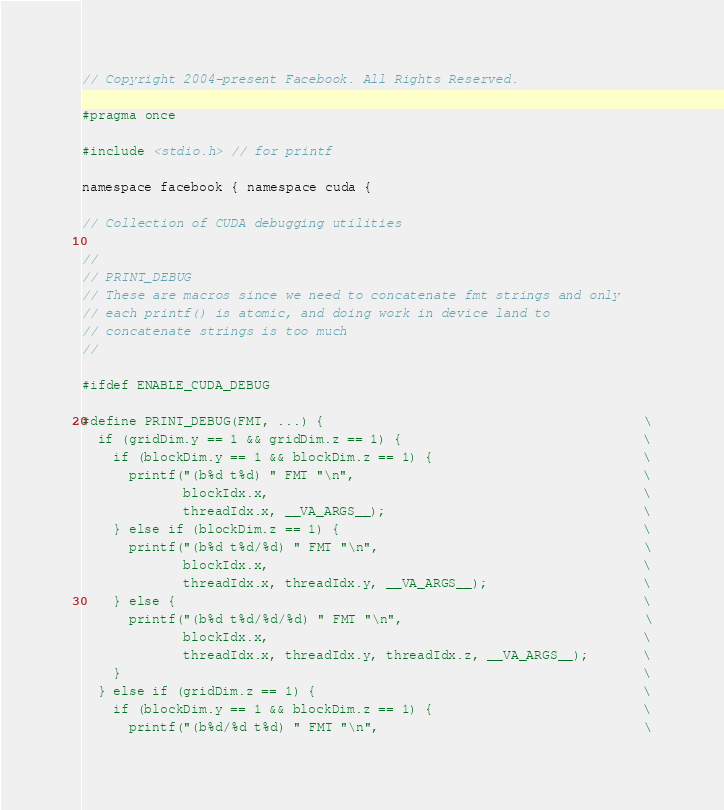Convert code to text. <code><loc_0><loc_0><loc_500><loc_500><_Cuda_>// Copyright 2004-present Facebook. All Rights Reserved.

#pragma once

#include <stdio.h> // for printf

namespace facebook { namespace cuda {

// Collection of CUDA debugging utilities

//
// PRINT_DEBUG
// These are macros since we need to concatenate fmt strings and only
// each printf() is atomic, and doing work in device land to
// concatenate strings is too much
//

#ifdef ENABLE_CUDA_DEBUG

#define PRINT_DEBUG(FMT, ...) {                                         \
  if (gridDim.y == 1 && gridDim.z == 1) {                               \
    if (blockDim.y == 1 && blockDim.z == 1) {                           \
      printf("(b%d t%d) " FMT "\n",                                     \
             blockIdx.x,                                                \
             threadIdx.x, __VA_ARGS__);                                 \
    } else if (blockDim.z == 1) {                                       \
      printf("(b%d t%d/%d) " FMT "\n",                                  \
             blockIdx.x,                                                \
             threadIdx.x, threadIdx.y, __VA_ARGS__);                    \
    } else {                                                            \
      printf("(b%d t%d/%d/%d) " FMT "\n",                               \
             blockIdx.x,                                                \
             threadIdx.x, threadIdx.y, threadIdx.z, __VA_ARGS__);       \
    }                                                                   \
  } else if (gridDim.z == 1) {                                          \
    if (blockDim.y == 1 && blockDim.z == 1) {                           \
      printf("(b%d/%d t%d) " FMT "\n",                                  \</code> 